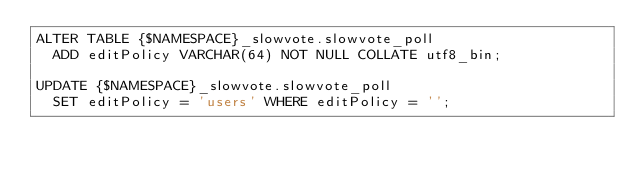<code> <loc_0><loc_0><loc_500><loc_500><_SQL_>ALTER TABLE {$NAMESPACE}_slowvote.slowvote_poll
  ADD editPolicy VARCHAR(64) NOT NULL COLLATE utf8_bin;

UPDATE {$NAMESPACE}_slowvote.slowvote_poll
  SET editPolicy = 'users' WHERE editPolicy = '';
</code> 